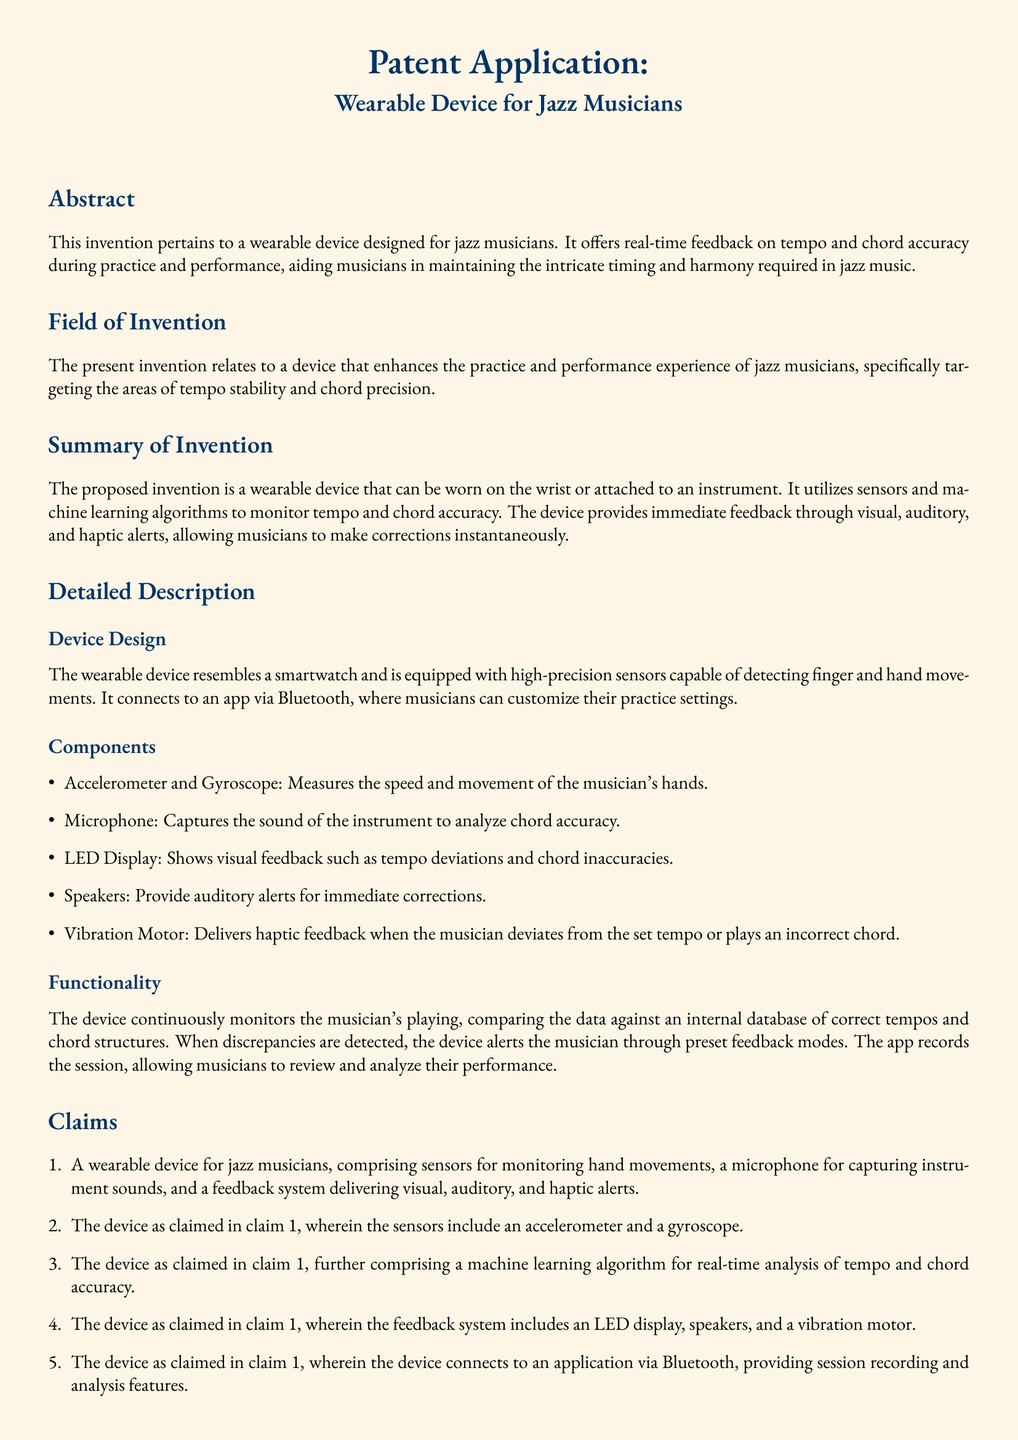What is the title of the invention? The title of the invention is specified in the document as "Wearable Device for Jazz Musicians."
Answer: Wearable Device for Jazz Musicians How does the wearable device provide feedback? The document states that the feedback is delivered through visual, auditory, and haptic alerts.
Answer: Visual, auditory, and haptic alerts What components are included in the device? The document lists the components such as accelerometer, gyroscope, microphone, LED display, speakers, and vibration motor.
Answer: Accelerometer, gyroscope, microphone, LED display, speakers, vibration motor What technology is used for real-time analysis? It mentions that a machine learning algorithm is employed for real-time analysis of tempo and chord accuracy.
Answer: Machine learning algorithm On which part of the body can the device be worn? The document mentions that the device can be worn on the wrist or attached to an instrument.
Answer: Wrist or attached to an instrument What is the primary field of invention? The primary field of invention focuses on enhancing the practice and performance experience of jazz musicians.
Answer: Enhancing practice and performance experience of jazz musicians How does the device connect to the app? The device connects to the app via Bluetooth, as stated in the document.
Answer: Bluetooth What type of musician is this device specifically designed for? The document specifies that the device is designed for jazz musicians.
Answer: Jazz musicians 